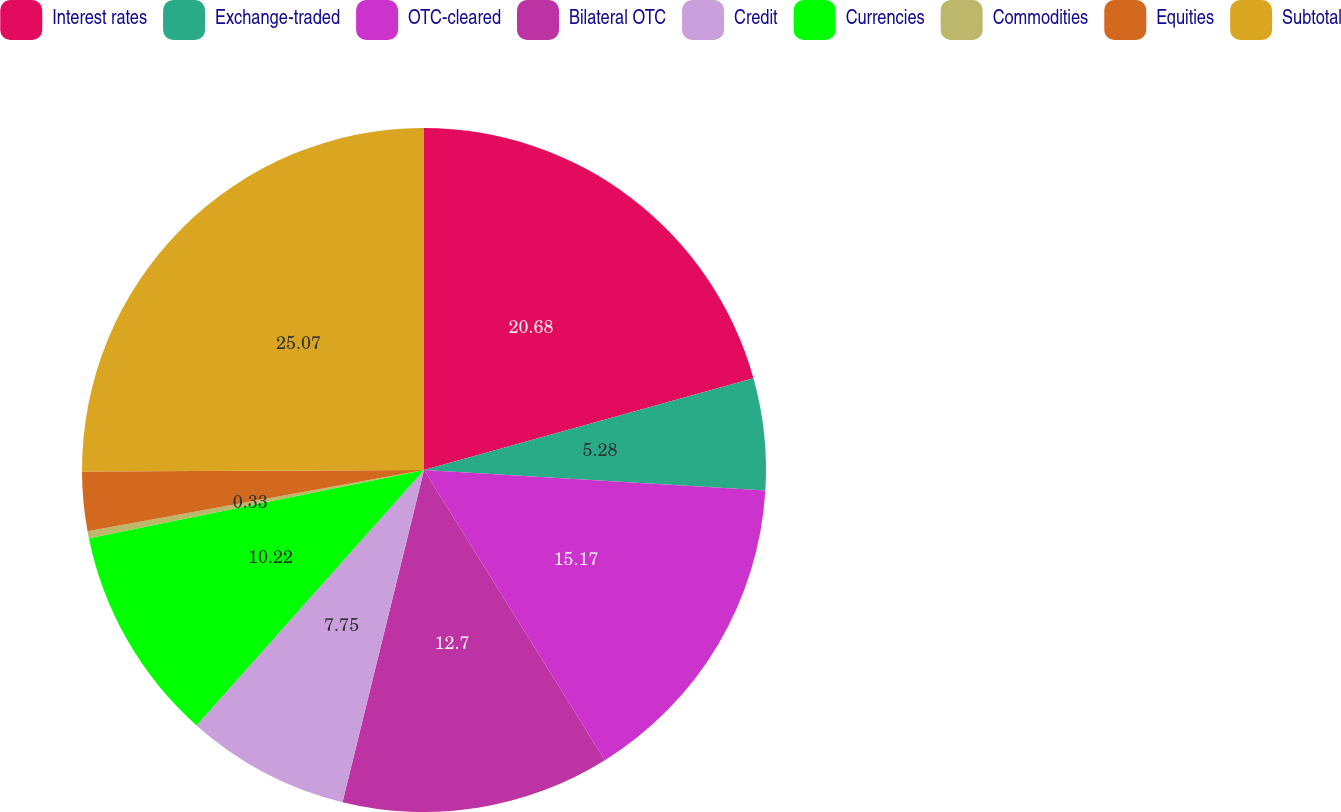<chart> <loc_0><loc_0><loc_500><loc_500><pie_chart><fcel>Interest rates<fcel>Exchange-traded<fcel>OTC-cleared<fcel>Bilateral OTC<fcel>Credit<fcel>Currencies<fcel>Commodities<fcel>Equities<fcel>Subtotal<nl><fcel>20.68%<fcel>5.28%<fcel>15.17%<fcel>12.7%<fcel>7.75%<fcel>10.22%<fcel>0.33%<fcel>2.8%<fcel>25.07%<nl></chart> 